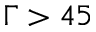Convert formula to latex. <formula><loc_0><loc_0><loc_500><loc_500>\Gamma > 4 5</formula> 